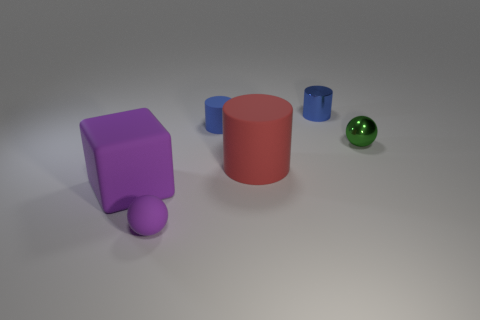Add 4 metal cylinders. How many objects exist? 10 Subtract all cubes. How many objects are left? 5 Add 1 small matte objects. How many small matte objects exist? 3 Subtract 2 blue cylinders. How many objects are left? 4 Subtract all small matte blocks. Subtract all big red things. How many objects are left? 5 Add 2 purple matte objects. How many purple matte objects are left? 4 